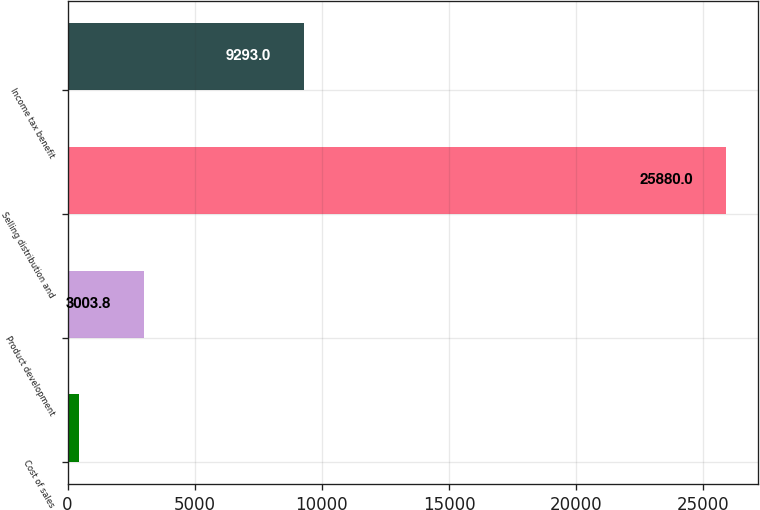Convert chart to OTSL. <chart><loc_0><loc_0><loc_500><loc_500><bar_chart><fcel>Cost of sales<fcel>Product development<fcel>Selling distribution and<fcel>Income tax benefit<nl><fcel>462<fcel>3003.8<fcel>25880<fcel>9293<nl></chart> 